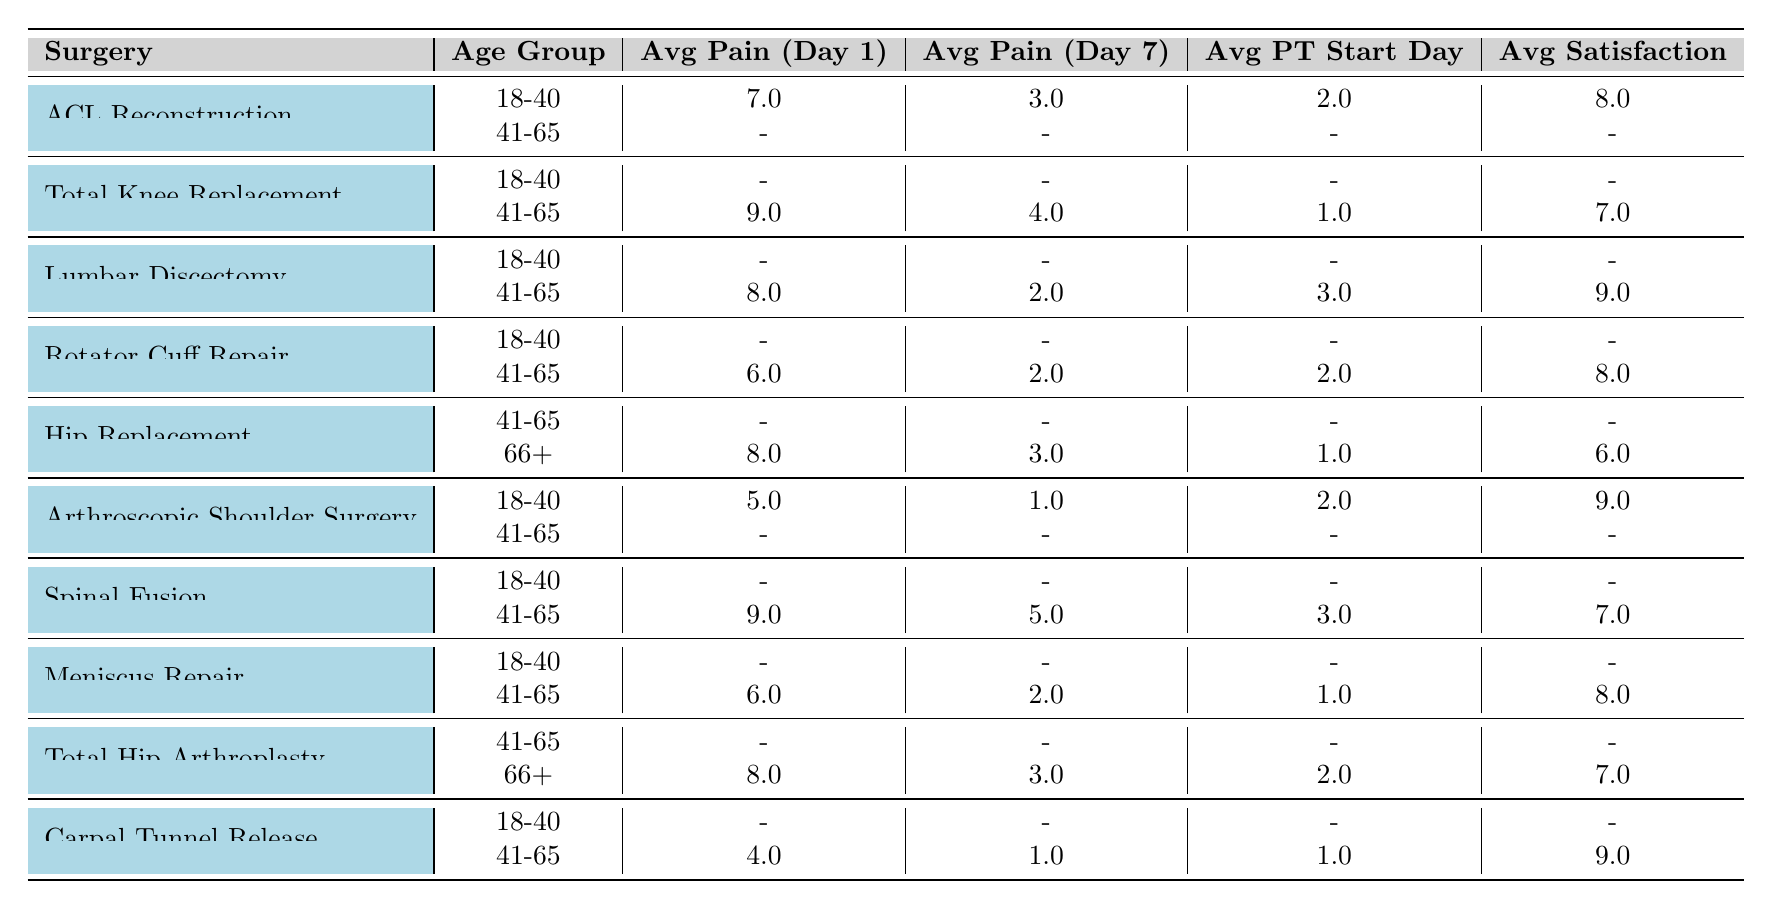What is the average pain score on Day 1 for ACL Reconstruction in the 18-40 age group? The table shows that, for ACL Reconstruction in the 18-40 age group, the average pain score on Day 1 is 7.0.
Answer: 7.0 What is the average satisfaction score for patients aged 66 and older who underwent Hip Replacement? According to the table, the average satisfaction score for patients aged 66+ who had Hip Replacement is 6.0.
Answer: 6.0 Is the average pain score on Day 7 for Total Knee Replacement in the age group 41-65 lower than for patients with Lumbar Discectomy in the same age group? The total average pain score on Day 7 for Total Knee Replacement in the 41-65 age group is 4.0, while for Lumbar Discectomy it is 2.0. Since 4.0 is higher than 2.0, the statement is false.
Answer: No What is the difference in average satisfaction score between patients aged 41-65 for Rotator Cuff Repair and those aged 41-65 for Lumbar Discectomy? The average satisfaction score for Rotator Cuff Repair in the 41-65 age group is 8.0, and for Lumbar Discectomy, it is 9.0. To find the difference, we calculate 9.0 - 8.0 = 1.0.
Answer: 1.0 What surgery has the highest average pain score on Day 1 for the age group 41-65? Looking at the table, the average pain score on Day 1 for both Total Knee Replacement and Spinal Fusion in the 41-65 age group is 9.0, which is the highest score.
Answer: Total Knee Replacement, Spinal Fusion What is the average start day for physical therapy for patients aged 41-65 after Rotator Cuff Repair? The table indicates no data for physical therapy start day in the 41-65 age group for Rotator Cuff Repair, which means it is logged as a dash indicating unavailability.
Answer: No data available Are there any patients aged 18-40 who had a surgery with a pain score on Day 1 lower than 5? The table shows no patient aged 18-40 with a pain score on Day 1 lower than 5, as the lowest score is 5.0 from Arthroscopic Shoulder Surgery in that age group.
Answer: No What is the average pain score reduction from Day 1 to Day 7 for Spinal Fusion in the age group 41-65? The average pain score for Spinal Fusion on Day 1 in the 41-65 age group is 9.0, and on Day 7 it is 5.0. The reduction is calculated as 9.0 - 5.0 = 4.0.
Answer: 4.0 